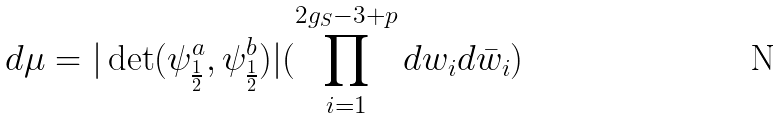Convert formula to latex. <formula><loc_0><loc_0><loc_500><loc_500>d \mu = { | \det ( \psi _ { \frac { 1 } { 2 } } ^ { a } , \psi _ { \frac { 1 } { 2 } } ^ { b } ) | } ( \prod _ { i = 1 } ^ { 2 g _ { S } - 3 + p } d w _ { i } d \bar { w } _ { i } )</formula> 